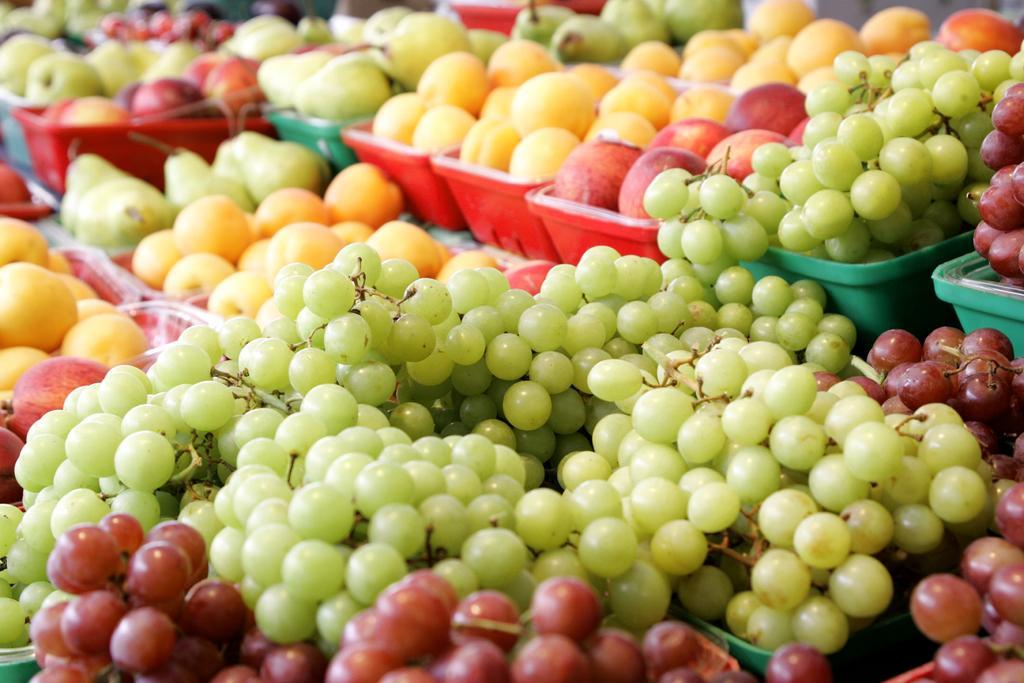Please provide a concise description of this image. In this picture we can see trays, there are some grapes, apples and other fruits present in these trays. 